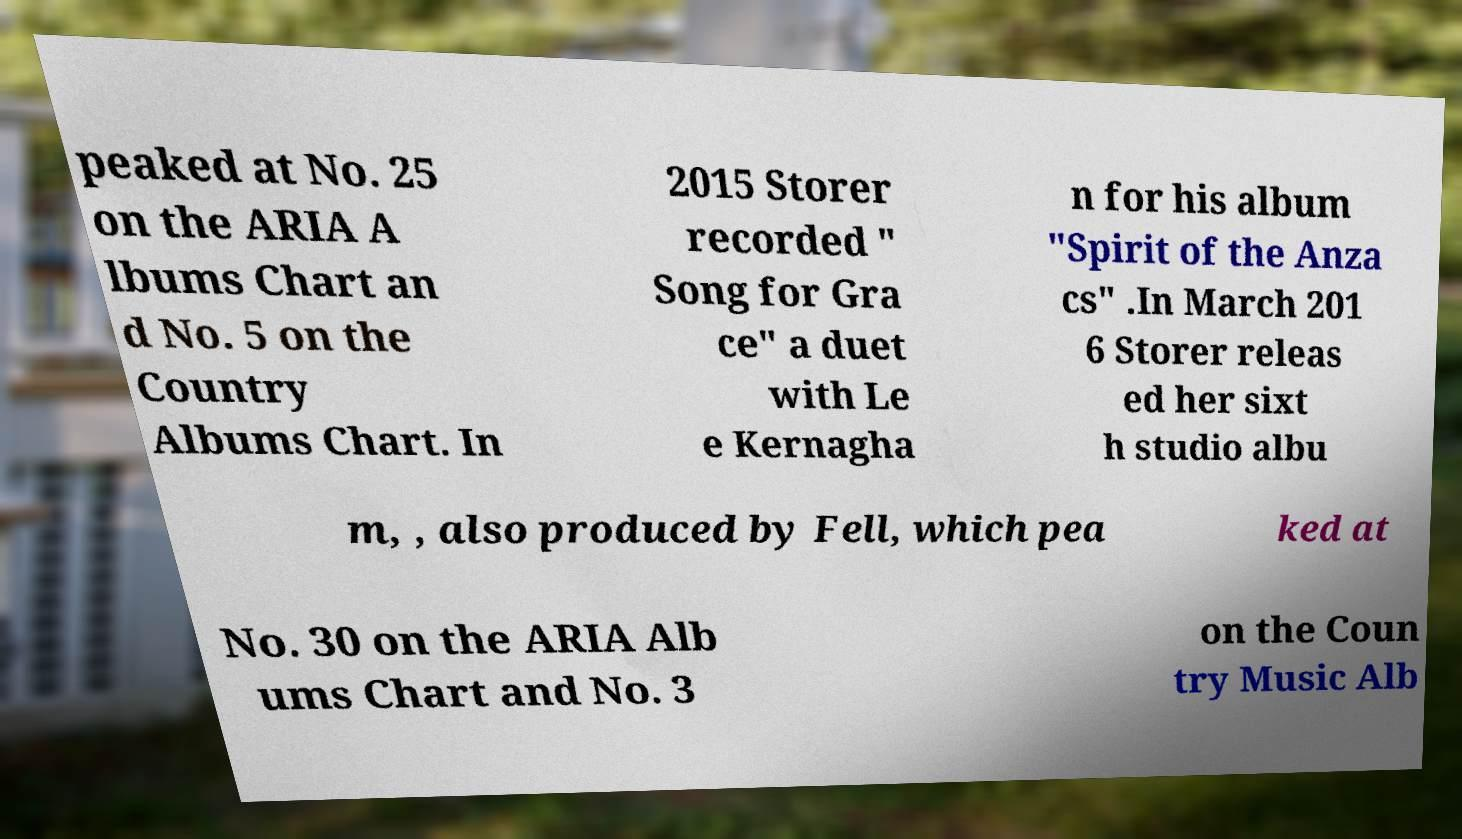What messages or text are displayed in this image? I need them in a readable, typed format. peaked at No. 25 on the ARIA A lbums Chart an d No. 5 on the Country Albums Chart. In 2015 Storer recorded " Song for Gra ce" a duet with Le e Kernagha n for his album "Spirit of the Anza cs" .In March 201 6 Storer releas ed her sixt h studio albu m, , also produced by Fell, which pea ked at No. 30 on the ARIA Alb ums Chart and No. 3 on the Coun try Music Alb 